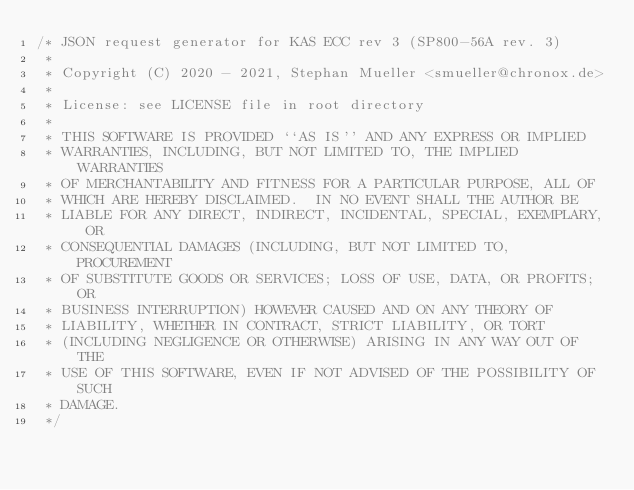<code> <loc_0><loc_0><loc_500><loc_500><_C_>/* JSON request generator for KAS ECC rev 3 (SP800-56A rev. 3)
 *
 * Copyright (C) 2020 - 2021, Stephan Mueller <smueller@chronox.de>
 *
 * License: see LICENSE file in root directory
 *
 * THIS SOFTWARE IS PROVIDED ``AS IS'' AND ANY EXPRESS OR IMPLIED
 * WARRANTIES, INCLUDING, BUT NOT LIMITED TO, THE IMPLIED WARRANTIES
 * OF MERCHANTABILITY AND FITNESS FOR A PARTICULAR PURPOSE, ALL OF
 * WHICH ARE HEREBY DISCLAIMED.  IN NO EVENT SHALL THE AUTHOR BE
 * LIABLE FOR ANY DIRECT, INDIRECT, INCIDENTAL, SPECIAL, EXEMPLARY, OR
 * CONSEQUENTIAL DAMAGES (INCLUDING, BUT NOT LIMITED TO, PROCUREMENT
 * OF SUBSTITUTE GOODS OR SERVICES; LOSS OF USE, DATA, OR PROFITS; OR
 * BUSINESS INTERRUPTION) HOWEVER CAUSED AND ON ANY THEORY OF
 * LIABILITY, WHETHER IN CONTRACT, STRICT LIABILITY, OR TORT
 * (INCLUDING NEGLIGENCE OR OTHERWISE) ARISING IN ANY WAY OUT OF THE
 * USE OF THIS SOFTWARE, EVEN IF NOT ADVISED OF THE POSSIBILITY OF SUCH
 * DAMAGE.
 */
</code> 